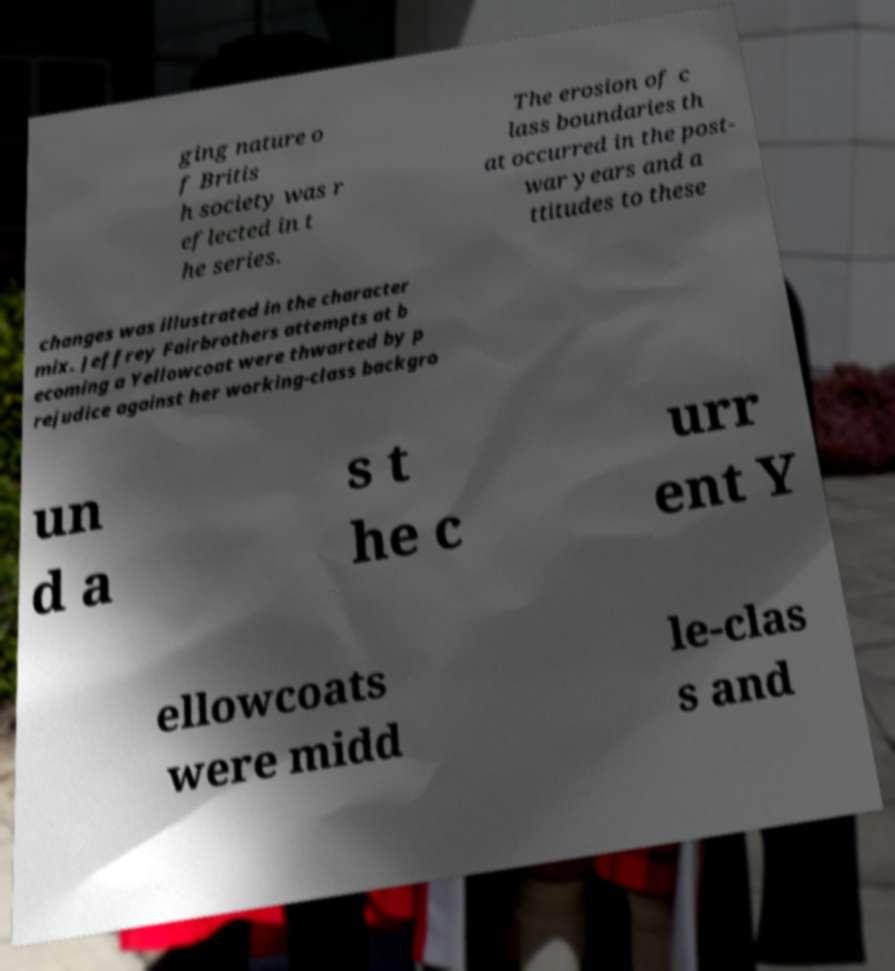There's text embedded in this image that I need extracted. Can you transcribe it verbatim? ging nature o f Britis h society was r eflected in t he series. The erosion of c lass boundaries th at occurred in the post- war years and a ttitudes to these changes was illustrated in the character mix. Jeffrey Fairbrothers attempts at b ecoming a Yellowcoat were thwarted by p rejudice against her working-class backgro un d a s t he c urr ent Y ellowcoats were midd le-clas s and 